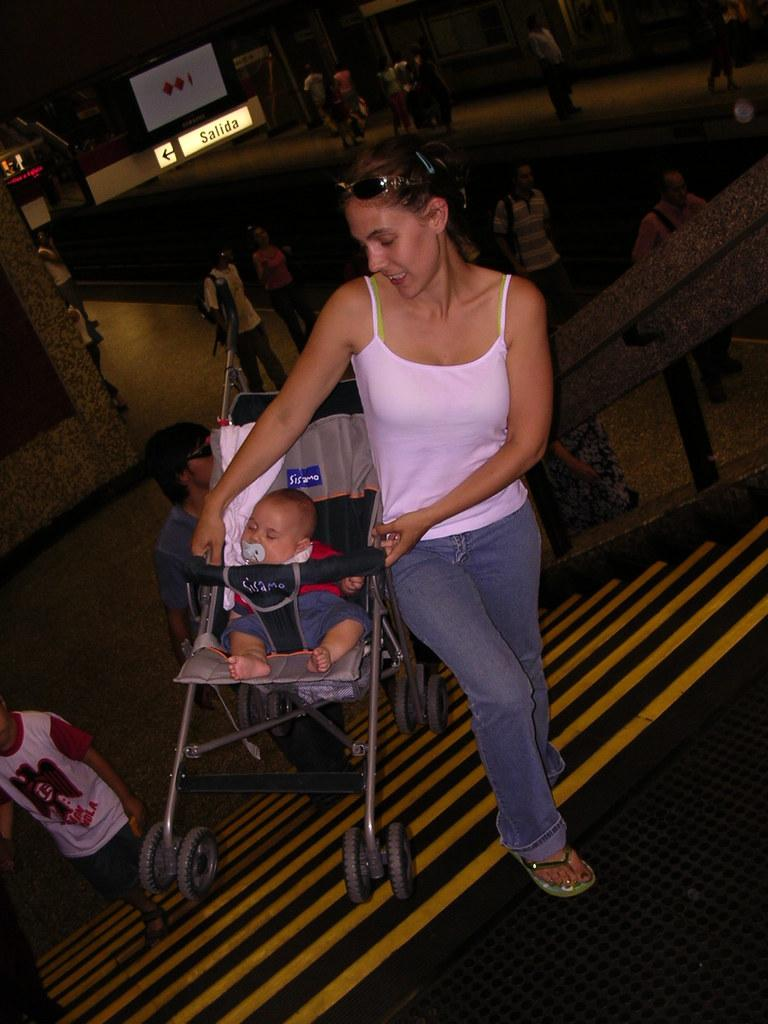<image>
Create a compact narrative representing the image presented. A woman carrying a stroller up a set of stairs with a sign in the background that reads Salida. 